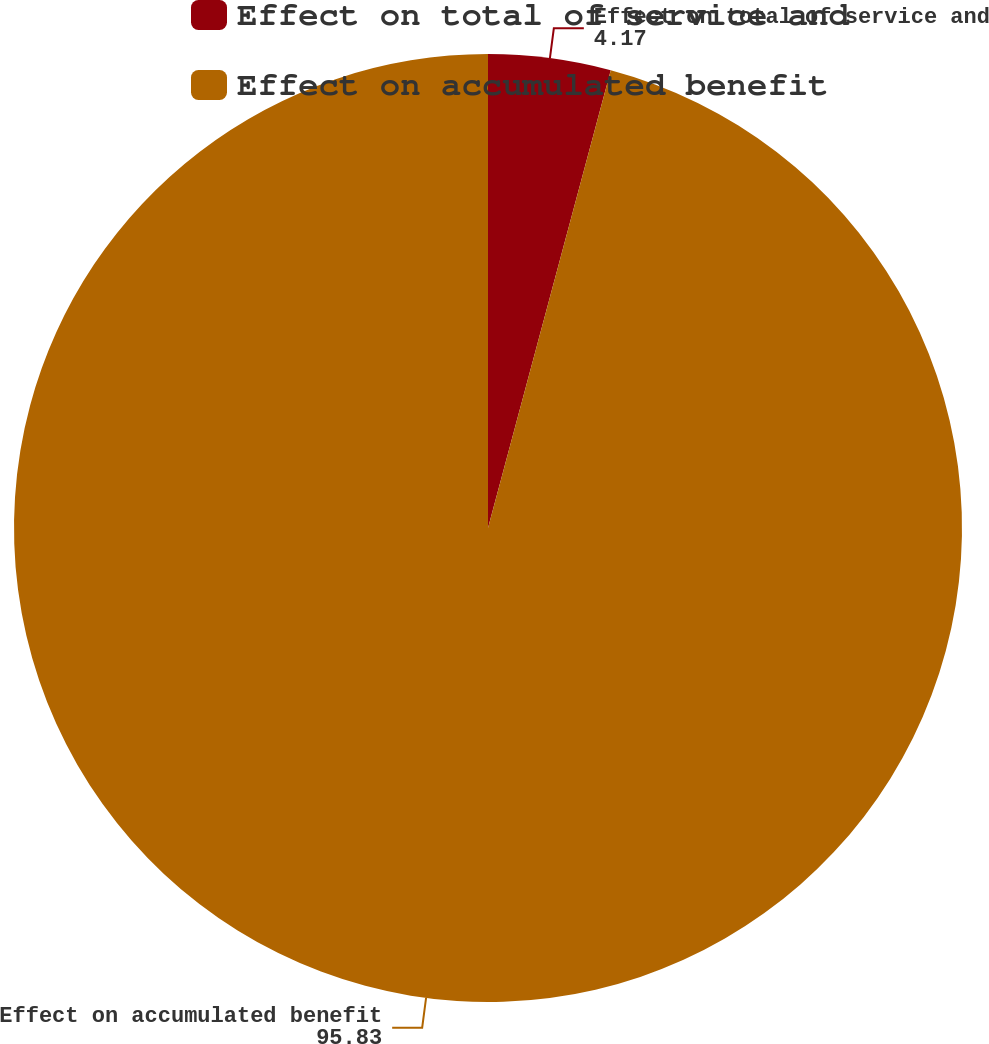<chart> <loc_0><loc_0><loc_500><loc_500><pie_chart><fcel>Effect on total of service and<fcel>Effect on accumulated benefit<nl><fcel>4.17%<fcel>95.83%<nl></chart> 